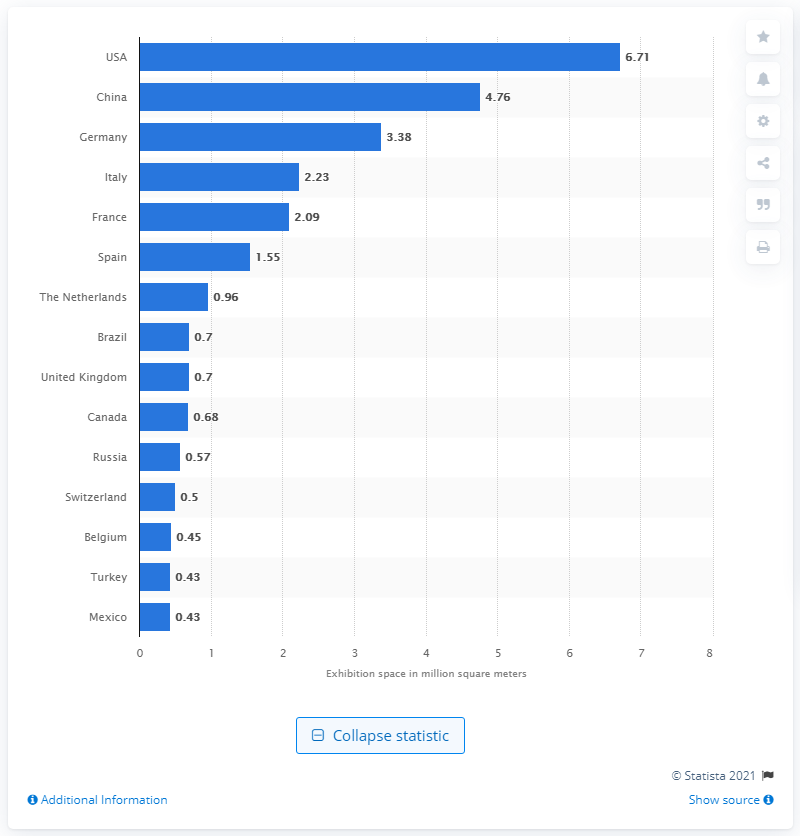Outline some significant characteristics in this image. In 2011, a total of 6.71 square meters of indoor venue exhibition space was available in the United States. 